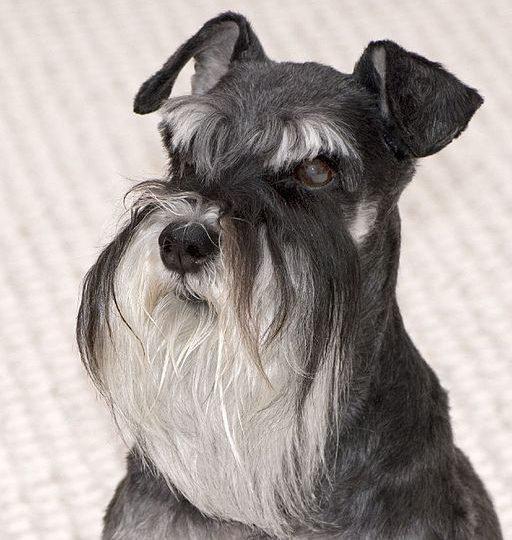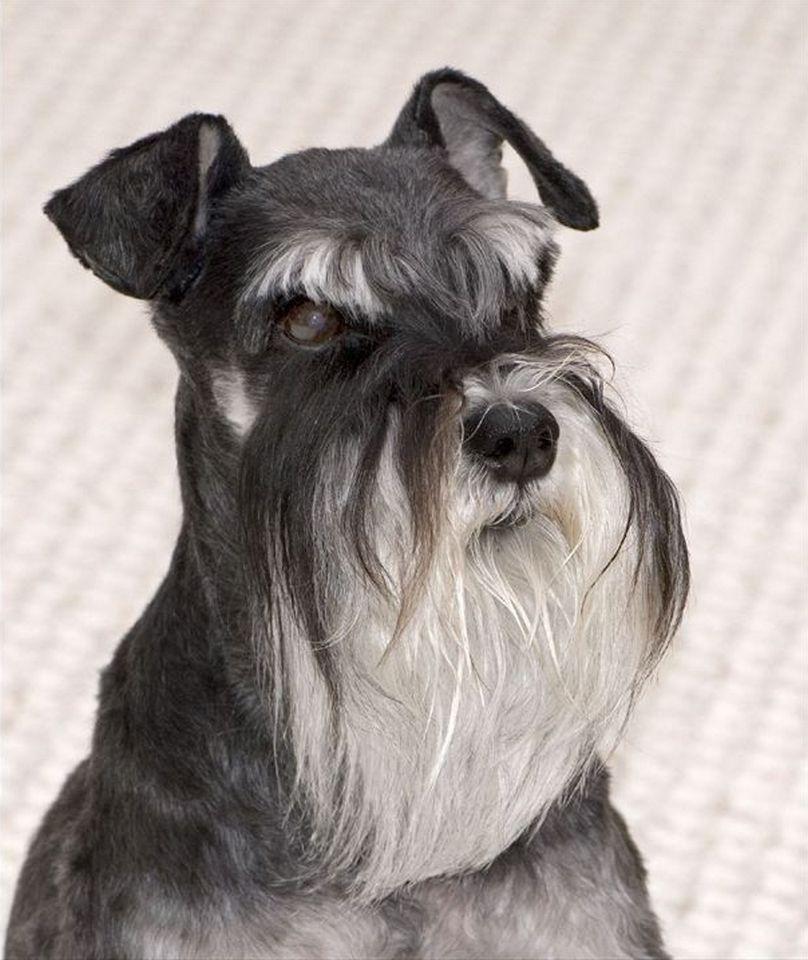The first image is the image on the left, the second image is the image on the right. Considering the images on both sides, is "Some type of animal figure is behind a forward-turned schnauzer dog in the left image." valid? Answer yes or no. No. The first image is the image on the left, the second image is the image on the right. Given the left and right images, does the statement "At least one of the dogs has its mouth open." hold true? Answer yes or no. No. 